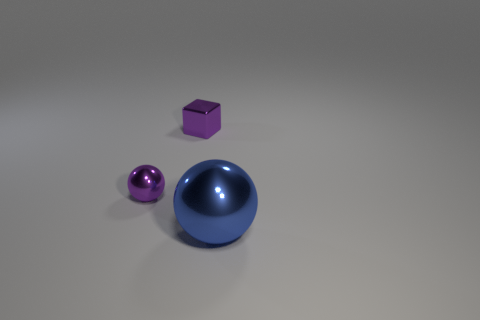There is a small sphere; is its color the same as the object that is behind the tiny sphere?
Give a very brief answer. Yes. How many metal spheres are in front of the small purple cube that is right of the tiny purple metal thing that is on the left side of the tiny metallic block?
Keep it short and to the point. 2. Are there any metal spheres on the right side of the purple shiny ball?
Offer a terse response. Yes. Is there any other thing that has the same color as the big shiny thing?
Provide a short and direct response. No. How many spheres are either small things or big objects?
Offer a very short reply. 2. How many metallic spheres are to the right of the small ball and behind the big shiny thing?
Make the answer very short. 0. Is the number of large metallic spheres that are behind the small purple metal ball the same as the number of purple metal things that are to the right of the small purple block?
Provide a succinct answer. Yes. Is the shape of the tiny thing behind the tiny purple sphere the same as  the blue shiny thing?
Keep it short and to the point. No. There is a small purple object that is in front of the small purple object to the right of the sphere that is to the left of the large metal thing; what shape is it?
Offer a very short reply. Sphere. The small shiny object that is the same color as the tiny shiny cube is what shape?
Your response must be concise. Sphere. 